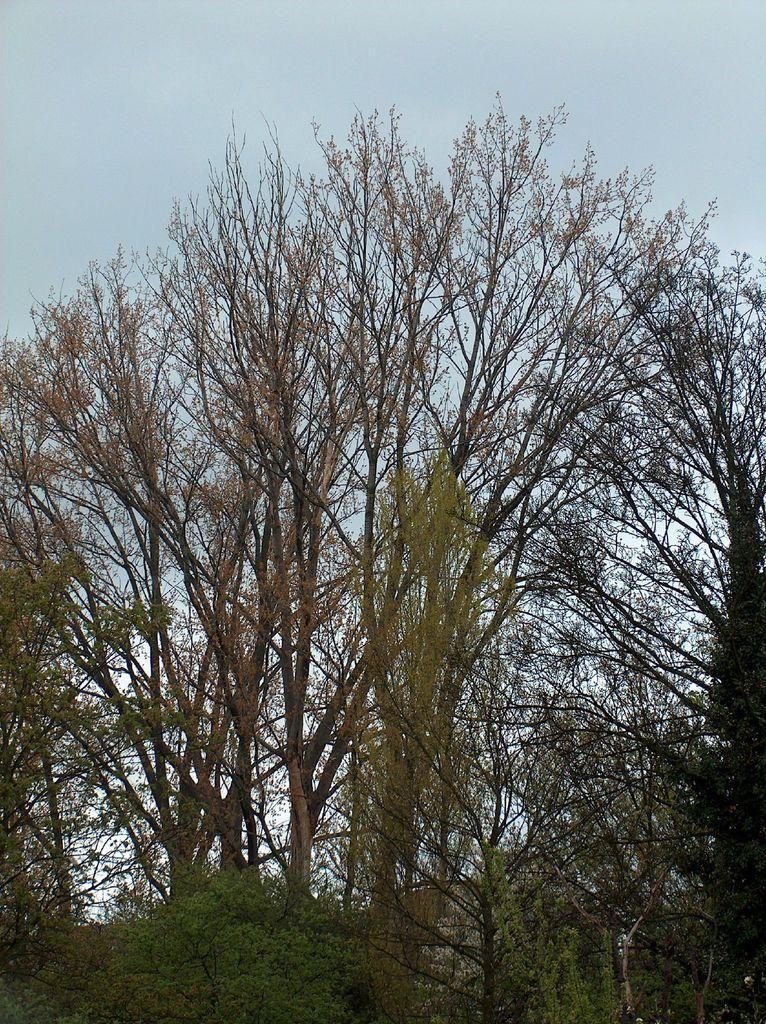How would you summarize this image in a sentence or two? In this picture we can see trees and we can see sky in the background. 